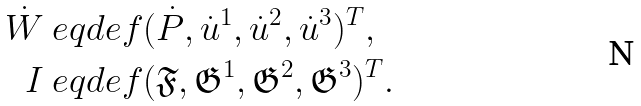<formula> <loc_0><loc_0><loc_500><loc_500>\dot { W } & \ e q d e f ( \dot { P } , \dot { u } ^ { 1 } , \dot { u } ^ { 2 } , \dot { u } ^ { 3 } ) ^ { T } , \\ I & \ e q d e f ( \mathfrak { F } , \mathfrak { G } ^ { 1 } , \mathfrak { G } ^ { 2 } , \mathfrak { G } ^ { 3 } ) ^ { T } .</formula> 